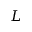<formula> <loc_0><loc_0><loc_500><loc_500>L</formula> 